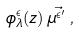Convert formula to latex. <formula><loc_0><loc_0><loc_500><loc_500>\phi ^ { \epsilon } _ { \lambda } ( z ) \, \vec { \mu ^ { \epsilon ^ { \prime } } } \, ,</formula> 